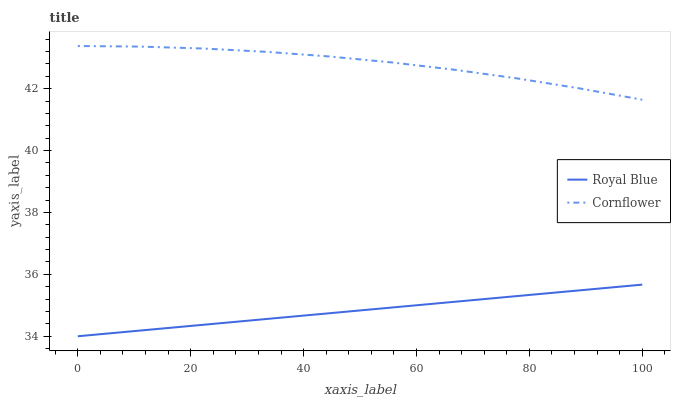Does Royal Blue have the minimum area under the curve?
Answer yes or no. Yes. Does Cornflower have the maximum area under the curve?
Answer yes or no. Yes. Does Cornflower have the minimum area under the curve?
Answer yes or no. No. Is Royal Blue the smoothest?
Answer yes or no. Yes. Is Cornflower the roughest?
Answer yes or no. Yes. Is Cornflower the smoothest?
Answer yes or no. No. Does Cornflower have the lowest value?
Answer yes or no. No. Does Cornflower have the highest value?
Answer yes or no. Yes. Is Royal Blue less than Cornflower?
Answer yes or no. Yes. Is Cornflower greater than Royal Blue?
Answer yes or no. Yes. Does Royal Blue intersect Cornflower?
Answer yes or no. No. 